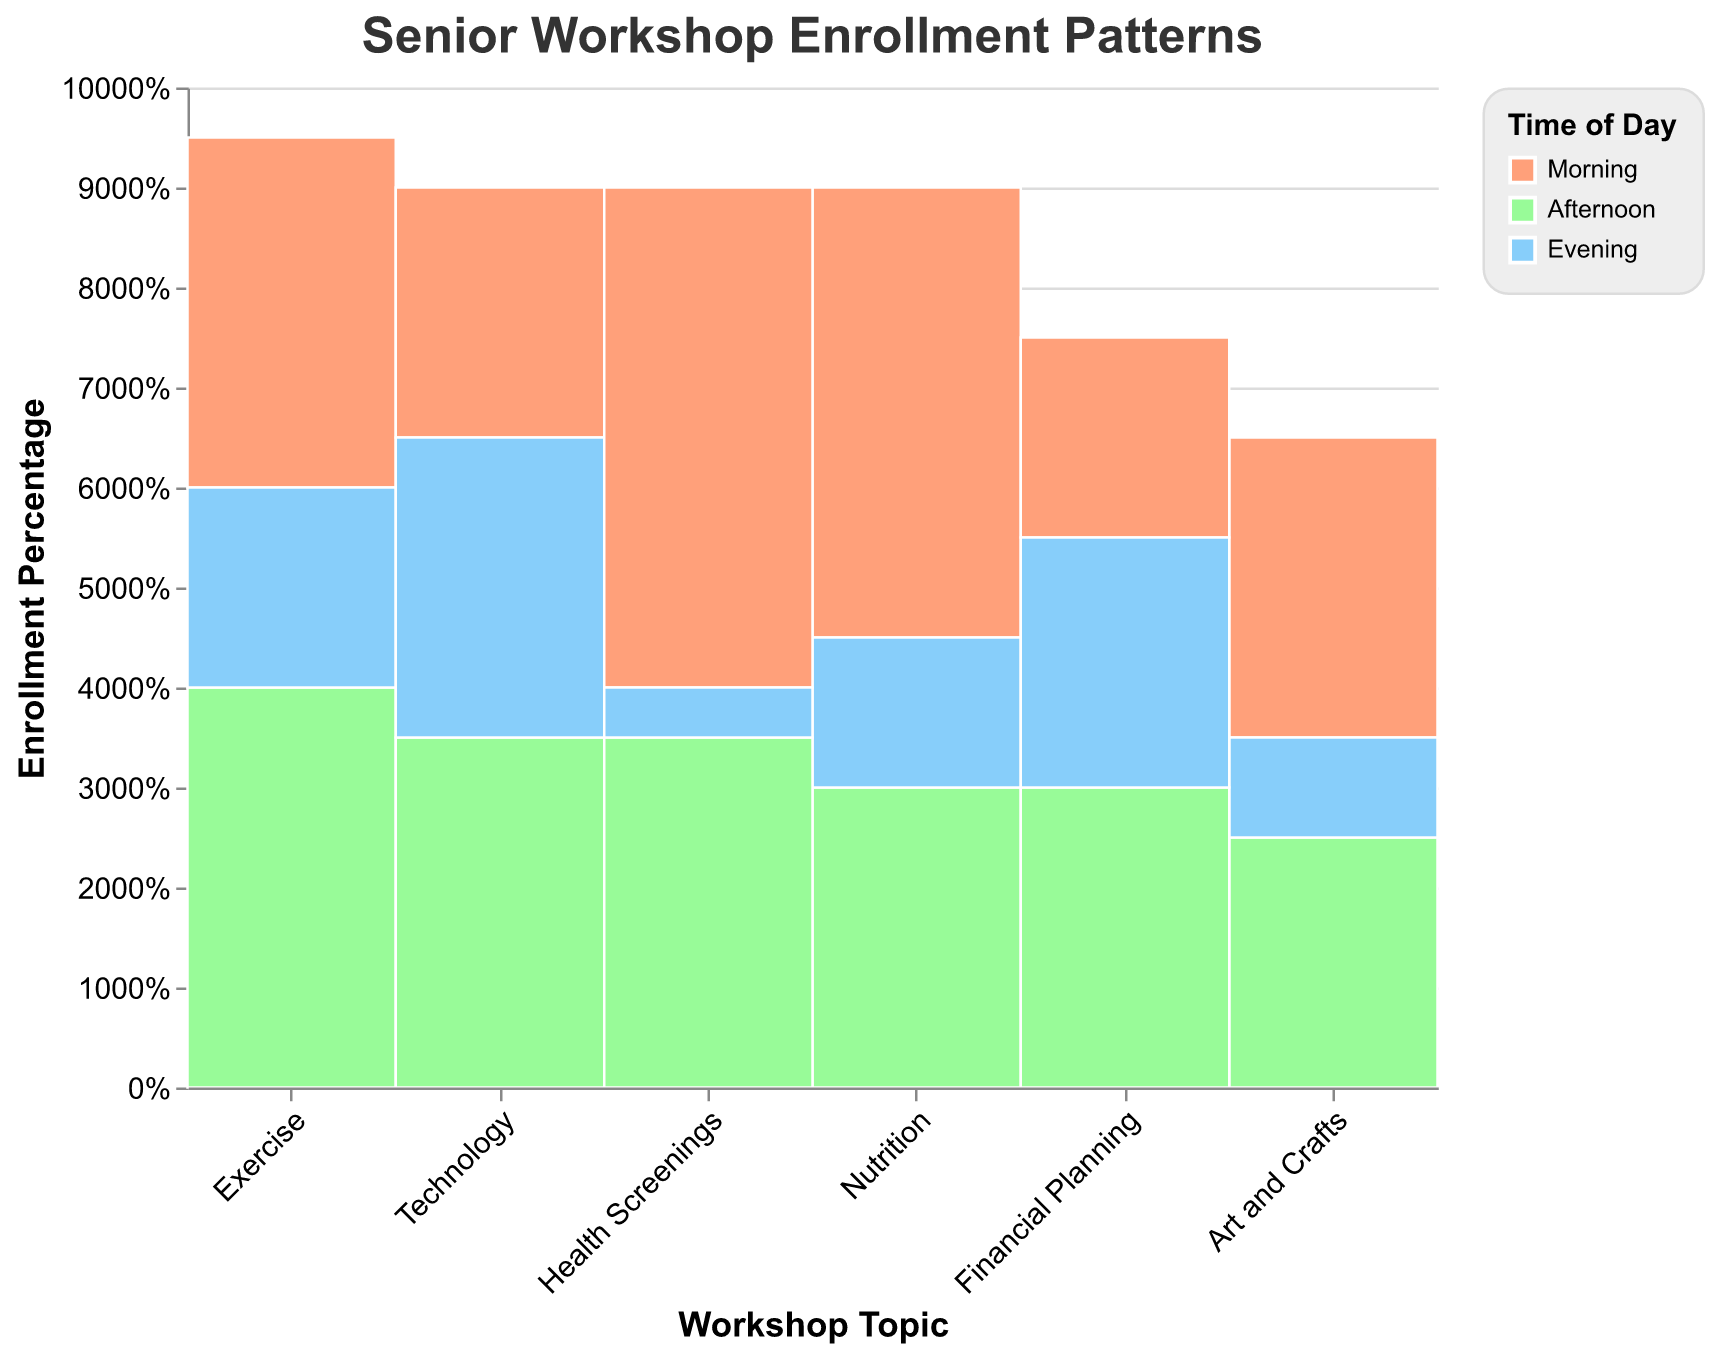What's the title of the figure? The title is displayed at the top of the figure and indicates that it is about the enrollment patterns of different senior workshops.
Answer: Senior Workshop Enrollment Patterns Which time of day shows the highest enrollment for Nutrition workshops? The Morning segment for Nutrition occupies the largest area in that section of the plot, indicating the highest enrollment.
Answer: Morning In which time slot does Exercise have the lowest enrollment? The Evening segment for the Exercise part of the plot is the smallest, indicating the lowest enrollment.
Answer: Evening Which workshop has a higher afternoon enrollment: Financial Planning or Technology? By comparing the Afternoon segments in both the Financial Planning and Technology sections, we see that both segments are roughly equal in size with Technology having a slightly larger portion.
Answer: Technology What percentage of the Health Screenings enrollments occurs in the morning? The height of the section for Morning within the Health Screenings part of the plot represents the proportion of morning enrollments relative to the total enrollments for Health Screenings. According to the tooltip, the Morning segment shows 50 enrollments out of a total of 90, which calculates to roughly 55.6%.
Answer: 55.6% Compare the enrollment pattern of the Nutrition workshop to the Exercise workshop. Which time of day has the highest enrollment for both, respectively? First, observe the tallest section for each workshop: for Nutrition, the Morning section is the tallest. For Exercise, the Afternoon section is the tallest.
Answer: Morning for Nutrition, Afternoon for Exercise How does the total enrollment for Art and Crafts compare with Health Screenings across all time slots? Adding up the enrollments in each time slot for both workshops, we see that Health Screenings have higher total enrollments (50+35+5 = 90) compared to Art and Crafts (30+25+10 = 65).
Answer: Health Screenings have higher total enrollment Which workshop shows the most balanced enrollment across different times of the day? The segments for each time of day within the Exercise section are relatively even in size, suggesting a more balanced enrollment distribution across Morning, Afternoon, and Evening. Exercise is the most balanced.
Answer: Exercise Is the evening attendance generally lower than other times of the day for all workshops? By scanning the plot, we notice that for most topics, the Evening sections are smaller compared to the Morning and Afternoon sections, indicating lower enrollments during the evening.
Answer: Yes Based on the plot, which workshops might benefit the most from holding additional morning sessions? Look for workshops where the Morning segments have noticeably large enrollments. Health Screenings and Nutrition workshops have significantly large Morning segments.
Answer: Health Screenings, Nutrition 